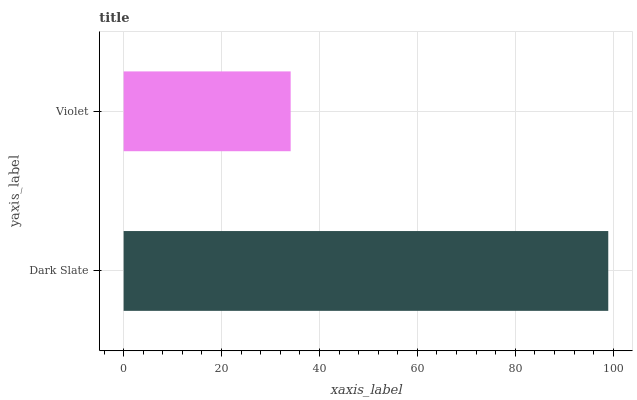Is Violet the minimum?
Answer yes or no. Yes. Is Dark Slate the maximum?
Answer yes or no. Yes. Is Violet the maximum?
Answer yes or no. No. Is Dark Slate greater than Violet?
Answer yes or no. Yes. Is Violet less than Dark Slate?
Answer yes or no. Yes. Is Violet greater than Dark Slate?
Answer yes or no. No. Is Dark Slate less than Violet?
Answer yes or no. No. Is Dark Slate the high median?
Answer yes or no. Yes. Is Violet the low median?
Answer yes or no. Yes. Is Violet the high median?
Answer yes or no. No. Is Dark Slate the low median?
Answer yes or no. No. 